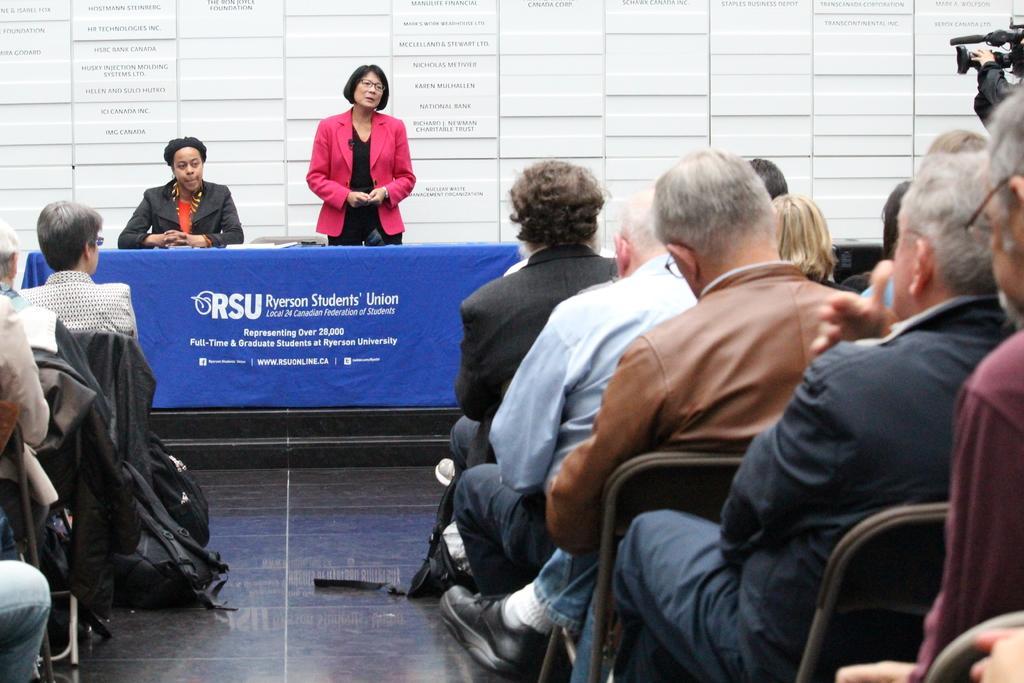Can you describe this image briefly? There are groups of people sitting on the chairs. This is a table, which is covered with a cloth. I can see the woman standing. These are the bags, which are placed on the floor. In the background, I think these are the name boards. On the right side of the image, I can see a person holding a video recorder. 